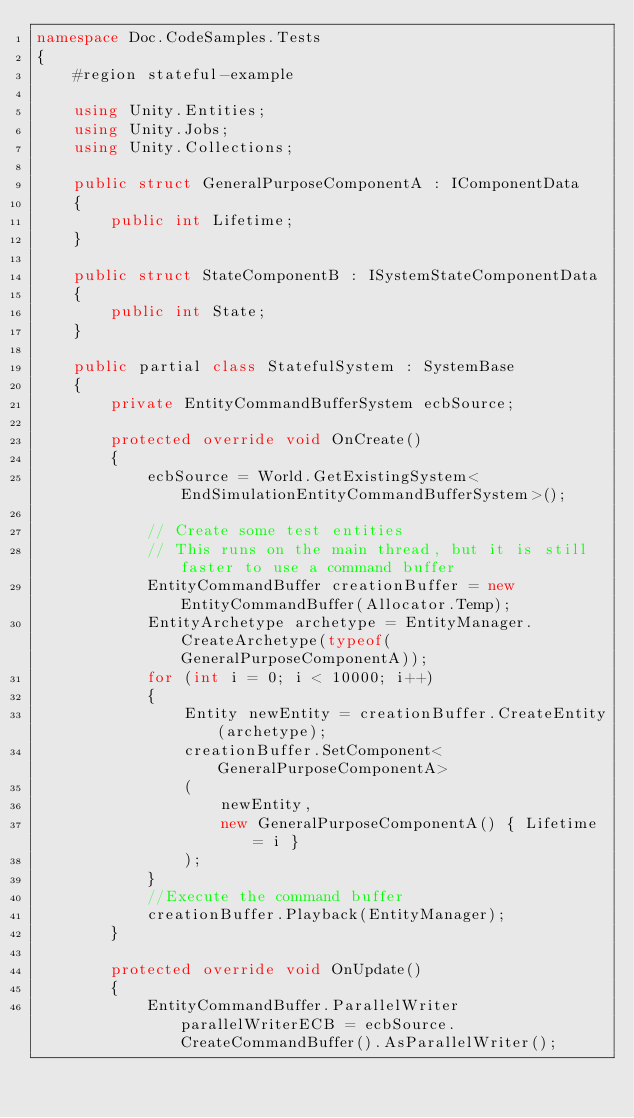Convert code to text. <code><loc_0><loc_0><loc_500><loc_500><_C#_>namespace Doc.CodeSamples.Tests
{
    #region stateful-example

    using Unity.Entities;
    using Unity.Jobs;
    using Unity.Collections;

    public struct GeneralPurposeComponentA : IComponentData
    {
        public int Lifetime;
    }

    public struct StateComponentB : ISystemStateComponentData
    {
        public int State;
    }

    public partial class StatefulSystem : SystemBase
    {
        private EntityCommandBufferSystem ecbSource;

        protected override void OnCreate()
        {
            ecbSource = World.GetExistingSystem<EndSimulationEntityCommandBufferSystem>();

            // Create some test entities
            // This runs on the main thread, but it is still faster to use a command buffer
            EntityCommandBuffer creationBuffer = new EntityCommandBuffer(Allocator.Temp);
            EntityArchetype archetype = EntityManager.CreateArchetype(typeof(GeneralPurposeComponentA));
            for (int i = 0; i < 10000; i++)
            {
                Entity newEntity = creationBuffer.CreateEntity(archetype);
                creationBuffer.SetComponent<GeneralPurposeComponentA>
                (
                    newEntity,
                    new GeneralPurposeComponentA() { Lifetime = i }
                );
            }
            //Execute the command buffer
            creationBuffer.Playback(EntityManager);
        }

        protected override void OnUpdate()
        {
            EntityCommandBuffer.ParallelWriter parallelWriterECB = ecbSource.CreateCommandBuffer().AsParallelWriter();
</code> 